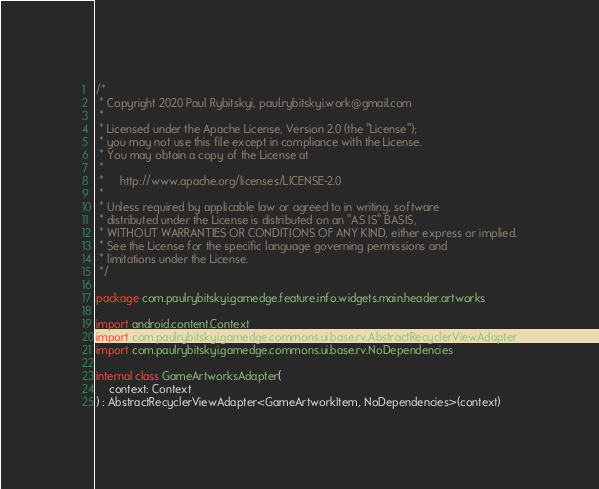<code> <loc_0><loc_0><loc_500><loc_500><_Kotlin_>/*
 * Copyright 2020 Paul Rybitskyi, paul.rybitskyi.work@gmail.com
 *
 * Licensed under the Apache License, Version 2.0 (the "License");
 * you may not use this file except in compliance with the License.
 * You may obtain a copy of the License at
 *
 *     http://www.apache.org/licenses/LICENSE-2.0
 *
 * Unless required by applicable law or agreed to in writing, software
 * distributed under the License is distributed on an "AS IS" BASIS,
 * WITHOUT WARRANTIES OR CONDITIONS OF ANY KIND, either express or implied.
 * See the License for the specific language governing permissions and
 * limitations under the License.
 */

package com.paulrybitskyi.gamedge.feature.info.widgets.main.header.artworks

import android.content.Context
import com.paulrybitskyi.gamedge.commons.ui.base.rv.AbstractRecyclerViewAdapter
import com.paulrybitskyi.gamedge.commons.ui.base.rv.NoDependencies

internal class GameArtworksAdapter(
    context: Context
) : AbstractRecyclerViewAdapter<GameArtworkItem, NoDependencies>(context)
</code> 